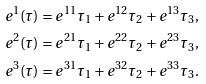<formula> <loc_0><loc_0><loc_500><loc_500>e ^ { 1 } ( \tau ) = e ^ { 1 1 } \tau _ { 1 } + e ^ { 1 2 } \tau _ { 2 } + e ^ { 1 3 } \tau _ { 3 } , \\ e ^ { 2 } ( \tau ) = e ^ { 2 1 } \tau _ { 1 } + e ^ { 2 2 } \tau _ { 2 } + e ^ { 2 3 } \tau _ { 3 } , \\ e ^ { 3 } ( \tau ) = e ^ { 3 1 } \tau _ { 1 } + e ^ { 3 2 } \tau _ { 2 } + e ^ { 3 3 } \tau _ { 3 } .</formula> 